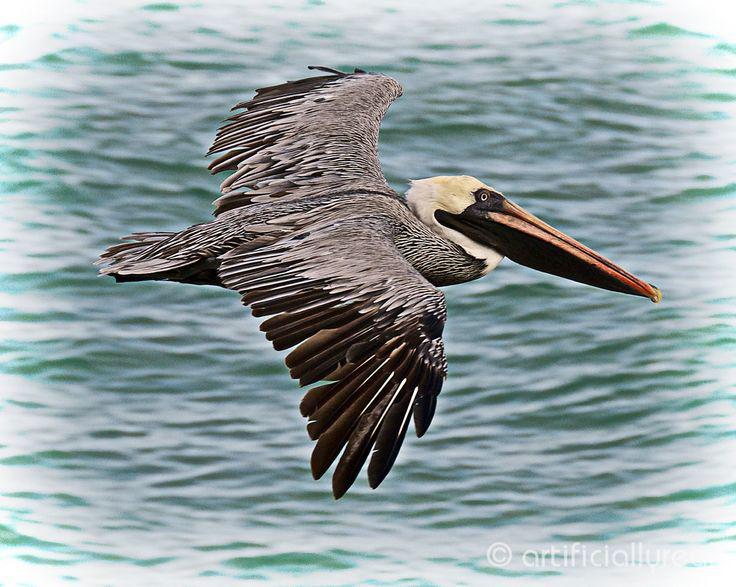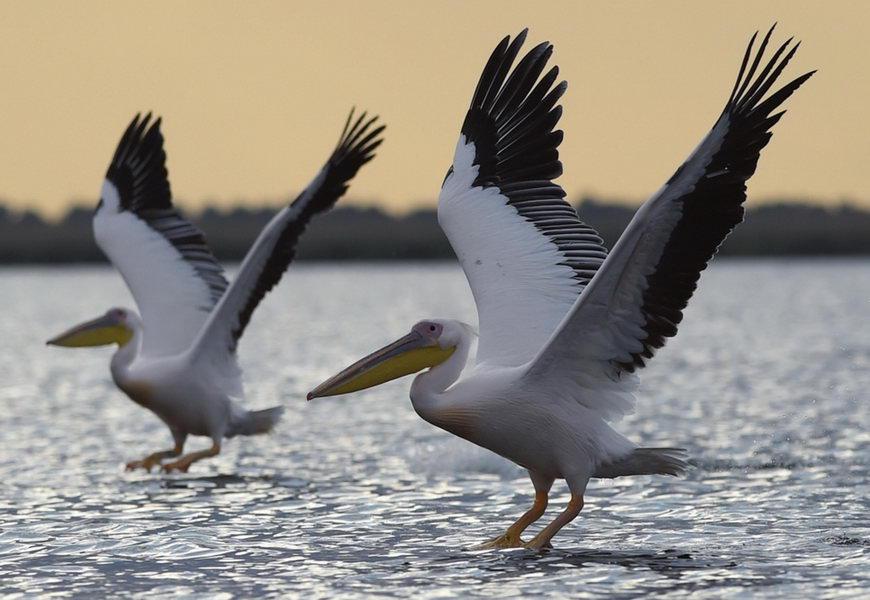The first image is the image on the left, the second image is the image on the right. Considering the images on both sides, is "An image shows a single gliding pelican with wings extended." valid? Answer yes or no. Yes. 